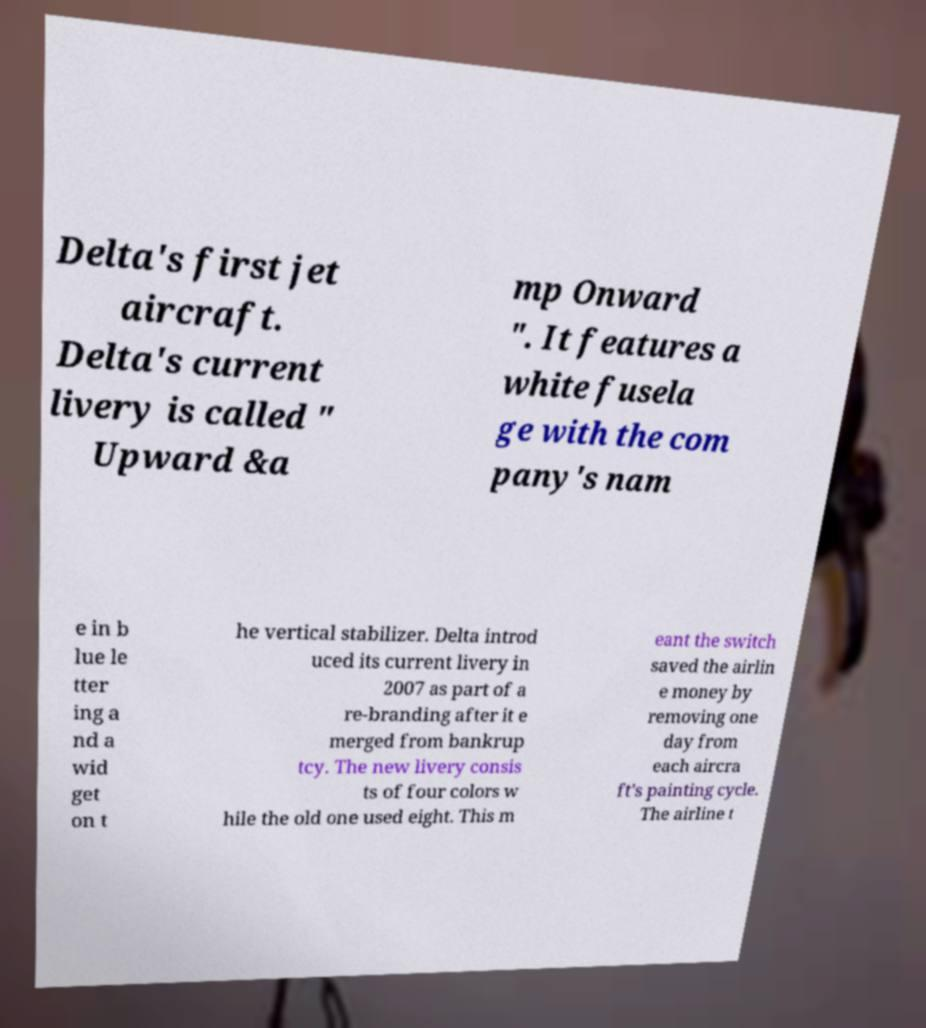Can you read and provide the text displayed in the image?This photo seems to have some interesting text. Can you extract and type it out for me? Delta's first jet aircraft. Delta's current livery is called " Upward &a mp Onward ". It features a white fusela ge with the com pany's nam e in b lue le tter ing a nd a wid get on t he vertical stabilizer. Delta introd uced its current livery in 2007 as part of a re-branding after it e merged from bankrup tcy. The new livery consis ts of four colors w hile the old one used eight. This m eant the switch saved the airlin e money by removing one day from each aircra ft's painting cycle. The airline t 